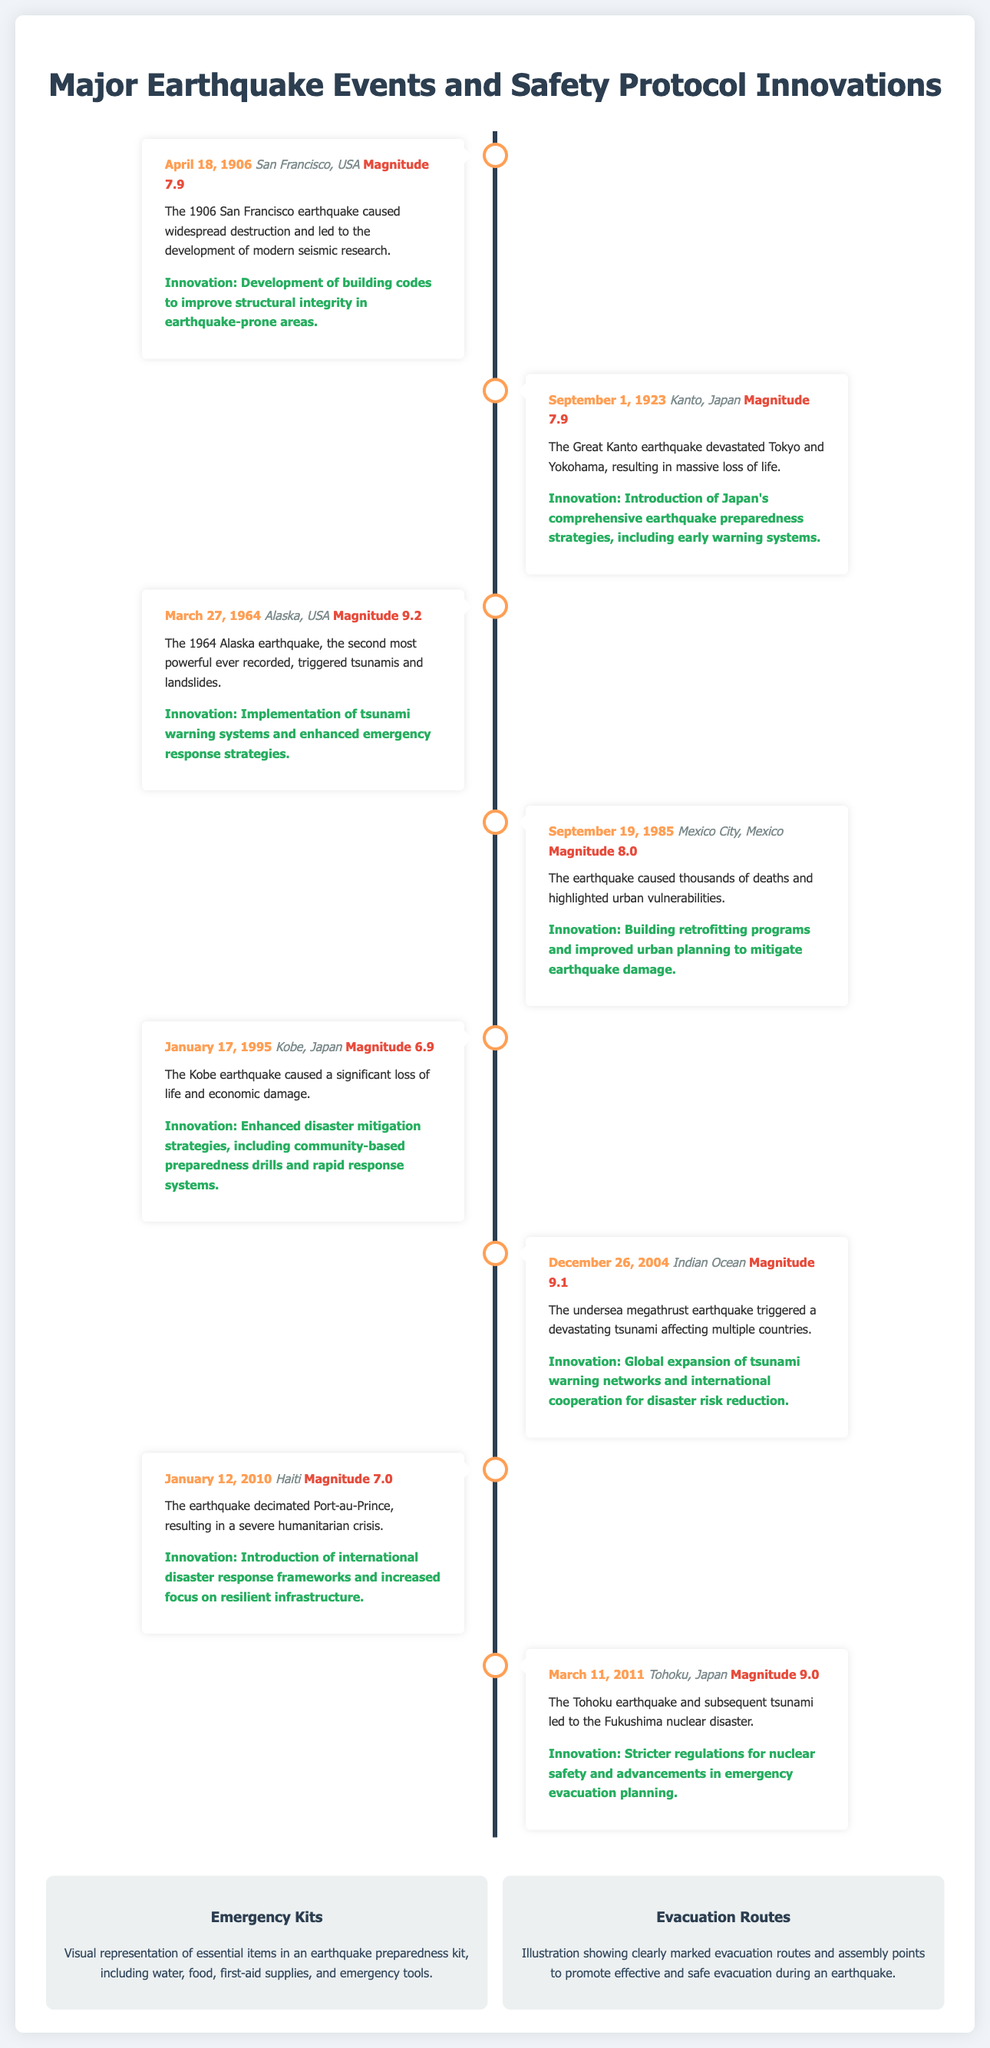What is the date of the San Francisco earthquake? The date can be found in the event information for the San Francisco earthquake in the document.
Answer: April 18, 1906 What was the magnitude of the earthquake in Haiti? The document specifies the magnitude of the Haiti earthquake in the corresponding event section.
Answer: Magnitude 7.0 Which city experienced the earthquake on September 19, 1985? The location of the earthquake on this date is mentioned in the related event section.
Answer: Mexico City, Mexico What innovation followed the Great Kanto earthquake? The innovation is described in the summary of events related to the Kanto earthquake in the document.
Answer: Japan's comprehensive earthquake preparedness strategies How many magnitude points did the Alaska earthquake register? This information is recorded in the Alaska earthquake event's details within the timeline.
Answer: Magnitude 9.2 What essential items are listed in the Emergency Kits visual? The visual description indicates the main items that should be included in an earthquake preparedness kit.
Answer: Water, food, first-aid supplies, emergency tools What disaster followed the Tohoku earthquake? The document describes the consequence of the Tohoku earthquake in relation to the event.
Answer: Fukushima nuclear disaster Which country introduced international disaster response frameworks after an earthquake? The document highlights the specific innovation related to the Haiti earthquake, indicating this country's response.
Answer: Haiti 